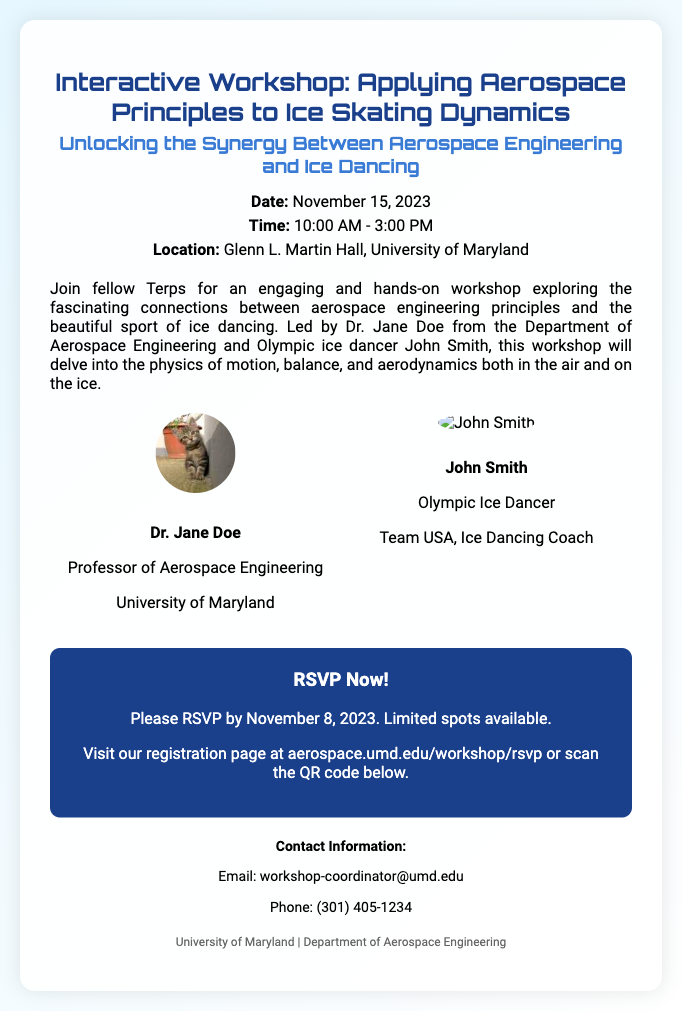what is the date of the workshop? The date of the workshop is mentioned in the document as November 15, 2023.
Answer: November 15, 2023 who are the facilitators of the workshop? The document lists Dr. Jane Doe and John Smith as the facilitators of the workshop.
Answer: Dr. Jane Doe and John Smith what is the location of the event? The document specifies that the workshop will be held at Glenn L. Martin Hall, University of Maryland.
Answer: Glenn L. Martin Hall, University of Maryland until when can participants RSVP? According to the RSVP information, participants can RSVP until November 8, 2023.
Answer: November 8, 2023 what is the theme of the workshop? The description section of the document mentions "Unlocking the Synergy Between Aerospace Engineering and Ice Dancing" as the workshop's theme.
Answer: Unlocking the Synergy Between Aerospace Engineering and Ice Dancing who is the Olympic ice dancer involved in the workshop? The document identifies John Smith as the Olympic ice dancer participating in the workshop.
Answer: John Smith what is the purpose of the workshop? The document describes the workshop's purpose as exploring connections between aerospace engineering principles and ice dancing.
Answer: Exploring connections between aerospace engineering principles and ice dancing how can one register for the workshop? The document instructs interested individuals to visit the registration page or scan the QR code for RSVP.
Answer: Visit the registration page or scan the QR code 